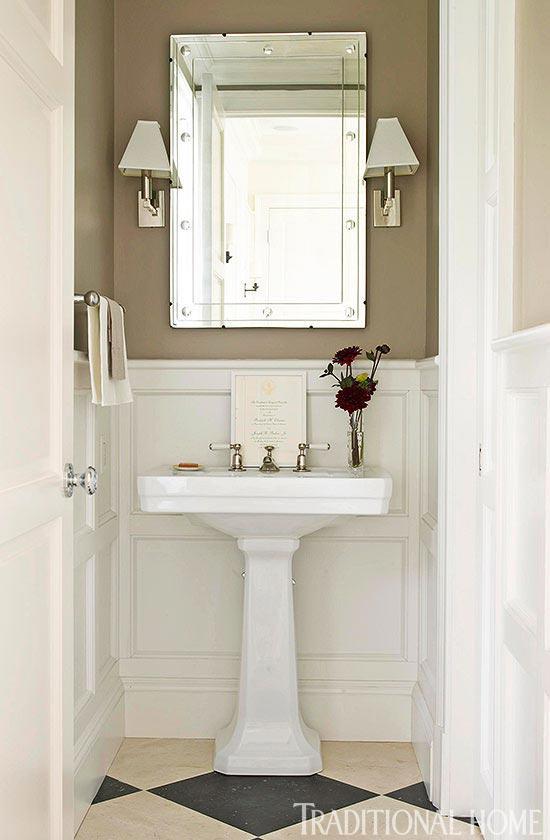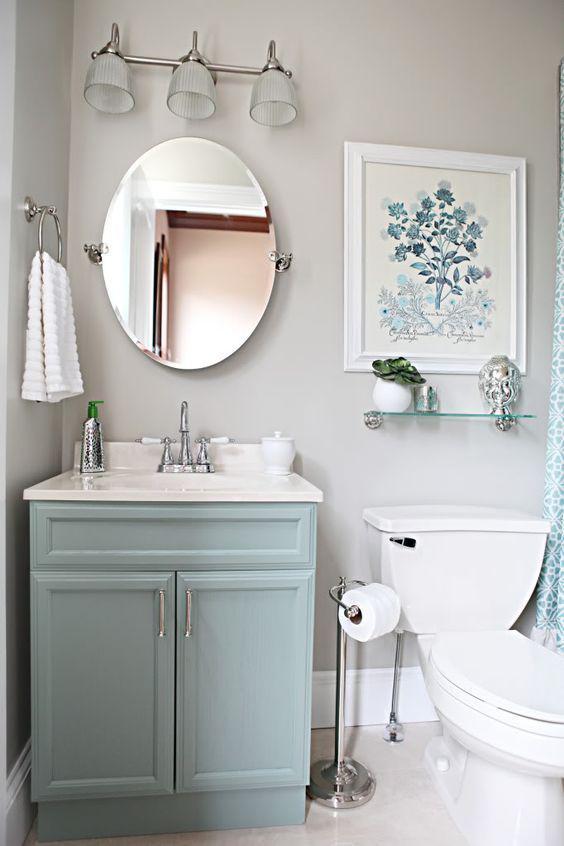The first image is the image on the left, the second image is the image on the right. Evaluate the accuracy of this statement regarding the images: "One bathroom features a rectangular mirror over a pedestal sink with a flower in a vase on it, and the other image shows a sink with a box-shaped vanity and a non-square mirror.". Is it true? Answer yes or no. Yes. The first image is the image on the left, the second image is the image on the right. Examine the images to the left and right. Is the description "One of the images features a sink with a cabinet underneath." accurate? Answer yes or no. Yes. 